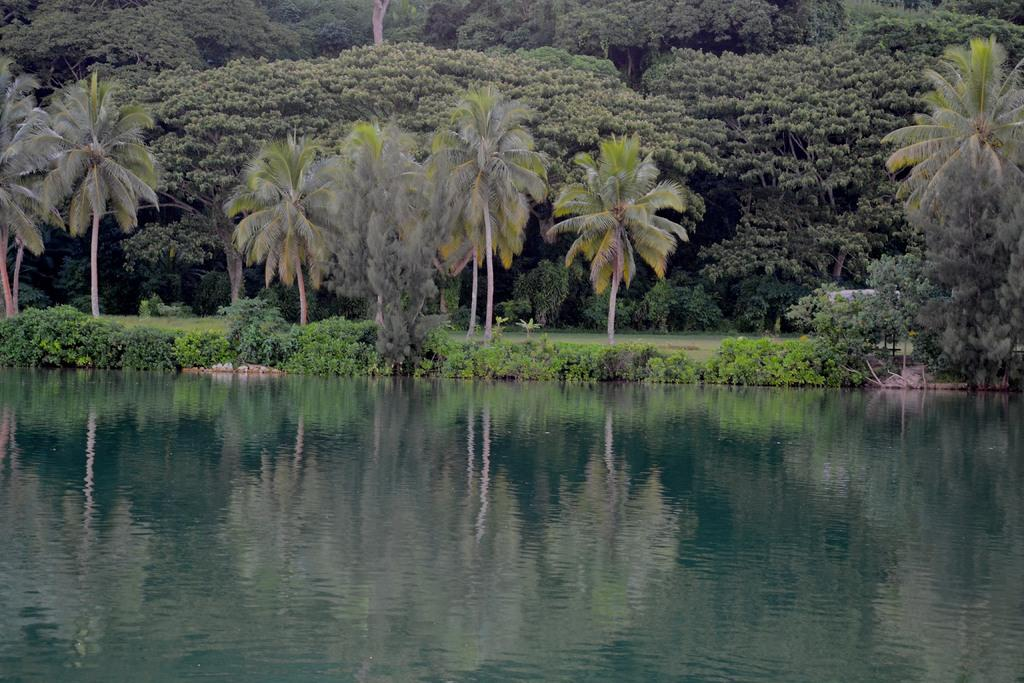What can be seen in the foreground of the image? There is water in the foreground of the image. What is visible in the background of the image? There are trees and plants in the background of the image. What type of reading material can be seen on the ground near the trees? There is no reading material present in the image; it features water in the foreground and trees and plants in the background. How many spiders are visible on the plants in the image? There are no spiders visible on the plants in the image. 